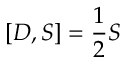<formula> <loc_0><loc_0><loc_500><loc_500>[ D , S ] = { \frac { 1 } { 2 } } S</formula> 